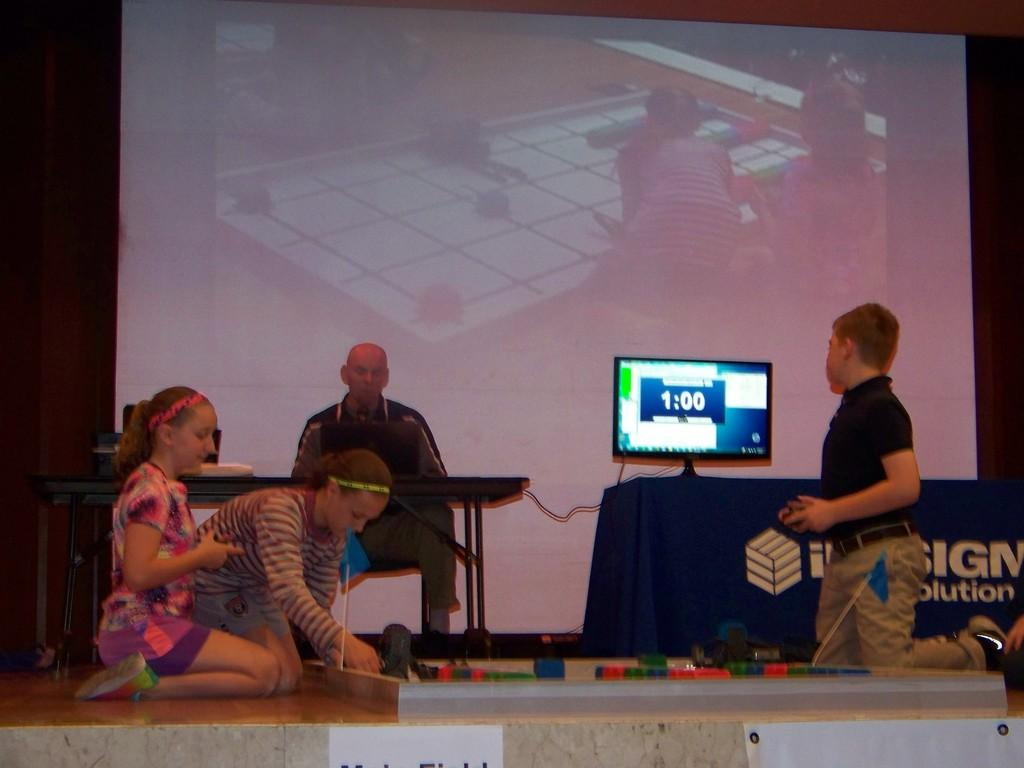Provide a one-sentence caption for the provided image. The kids are building blocks in a competition while they only have  minute left. 